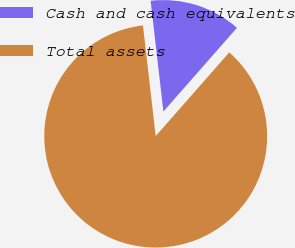Convert chart to OTSL. <chart><loc_0><loc_0><loc_500><loc_500><pie_chart><fcel>Cash and cash equivalents<fcel>Total assets<nl><fcel>13.3%<fcel>86.7%<nl></chart> 